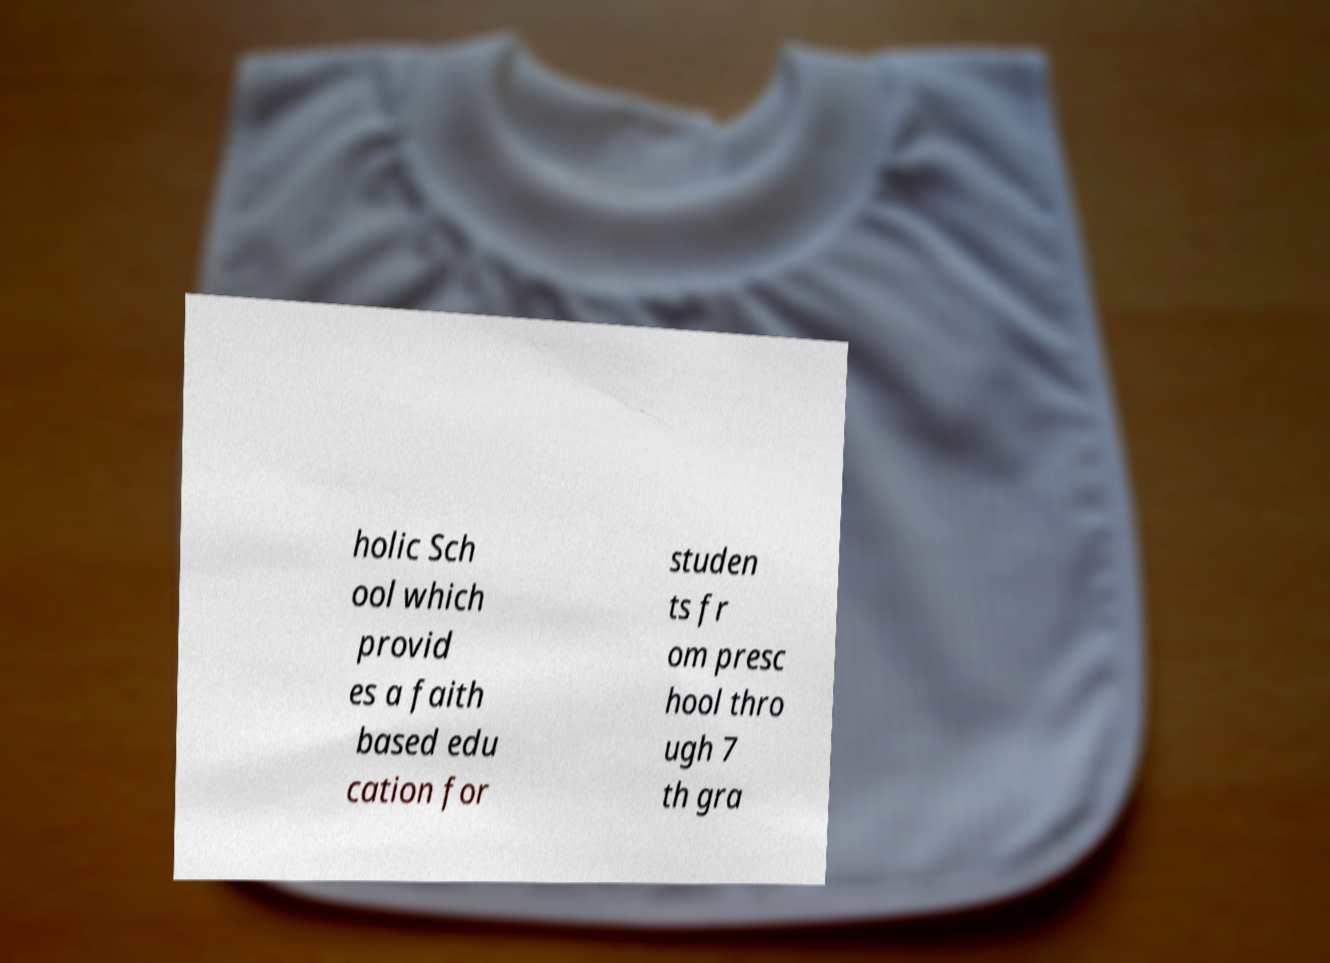Could you assist in decoding the text presented in this image and type it out clearly? holic Sch ool which provid es a faith based edu cation for studen ts fr om presc hool thro ugh 7 th gra 